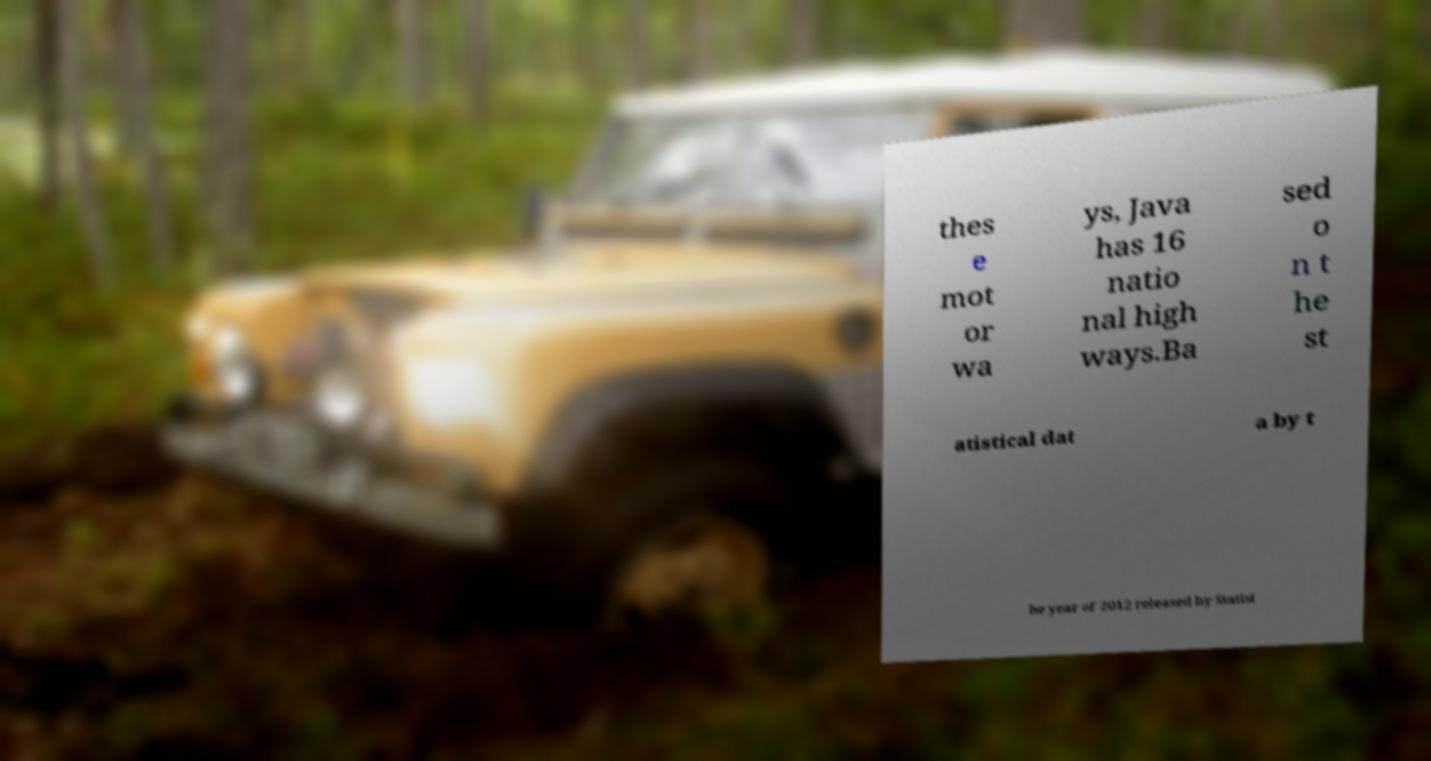Please read and relay the text visible in this image. What does it say? thes e mot or wa ys, Java has 16 natio nal high ways.Ba sed o n t he st atistical dat a by t he year of 2012 released by Statist 